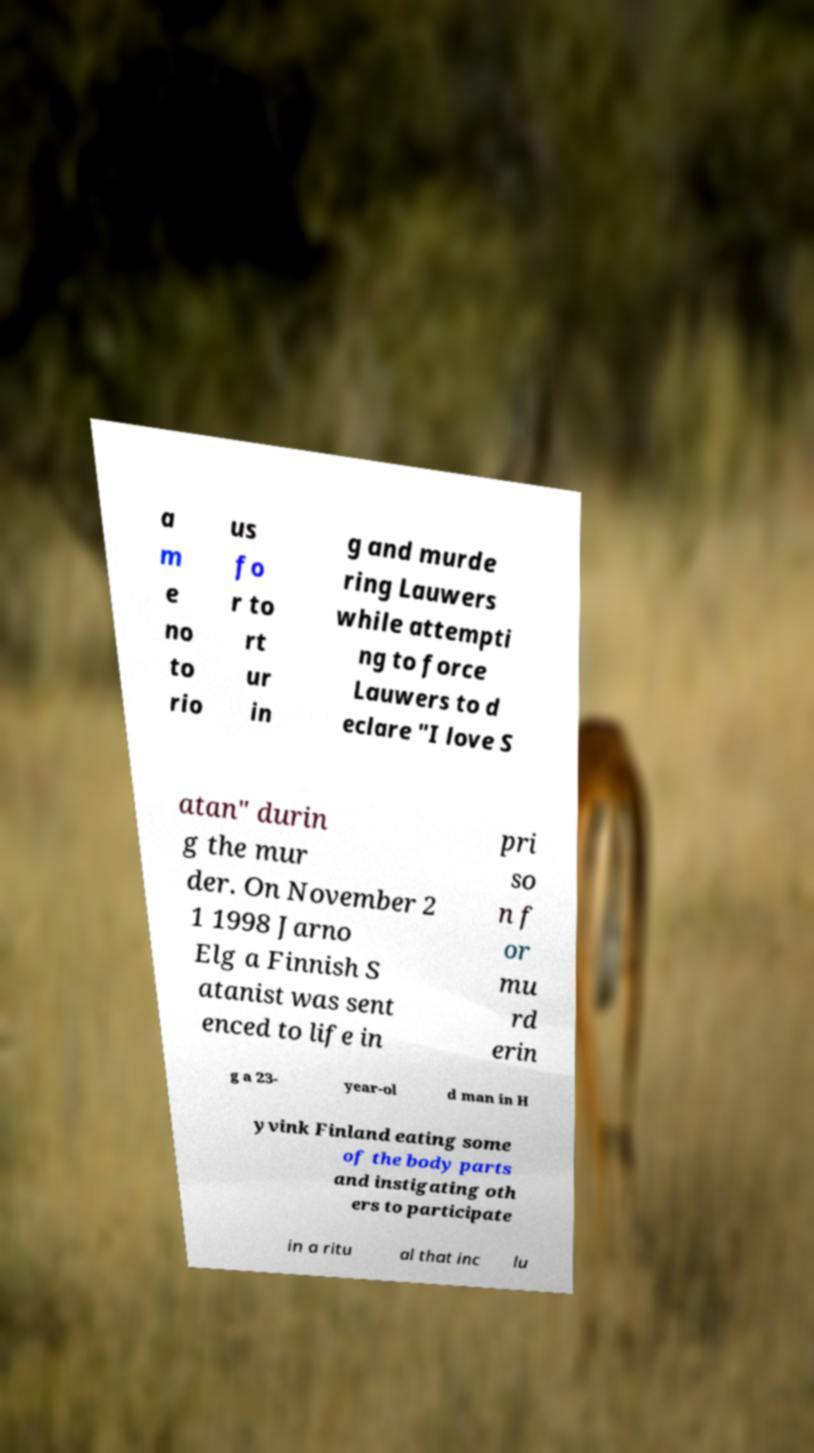Can you read and provide the text displayed in the image?This photo seems to have some interesting text. Can you extract and type it out for me? a m e no to rio us fo r to rt ur in g and murde ring Lauwers while attempti ng to force Lauwers to d eclare "I love S atan" durin g the mur der. On November 2 1 1998 Jarno Elg a Finnish S atanist was sent enced to life in pri so n f or mu rd erin g a 23- year-ol d man in H yvink Finland eating some of the body parts and instigating oth ers to participate in a ritu al that inc lu 